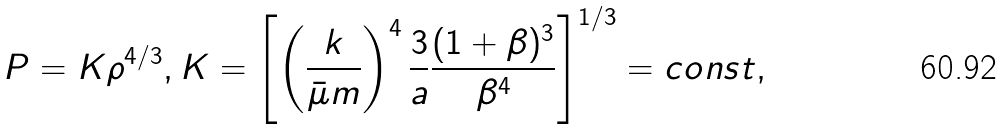Convert formula to latex. <formula><loc_0><loc_0><loc_500><loc_500>P = K \rho ^ { 4 / 3 } , K = \left [ \left ( \frac { k } { \bar { \mu } m } \right ) ^ { 4 } \frac { 3 } { a } \frac { ( 1 + \beta ) ^ { 3 } } { \beta ^ { 4 } } \right ] ^ { 1 / 3 } = c o n s t ,</formula> 